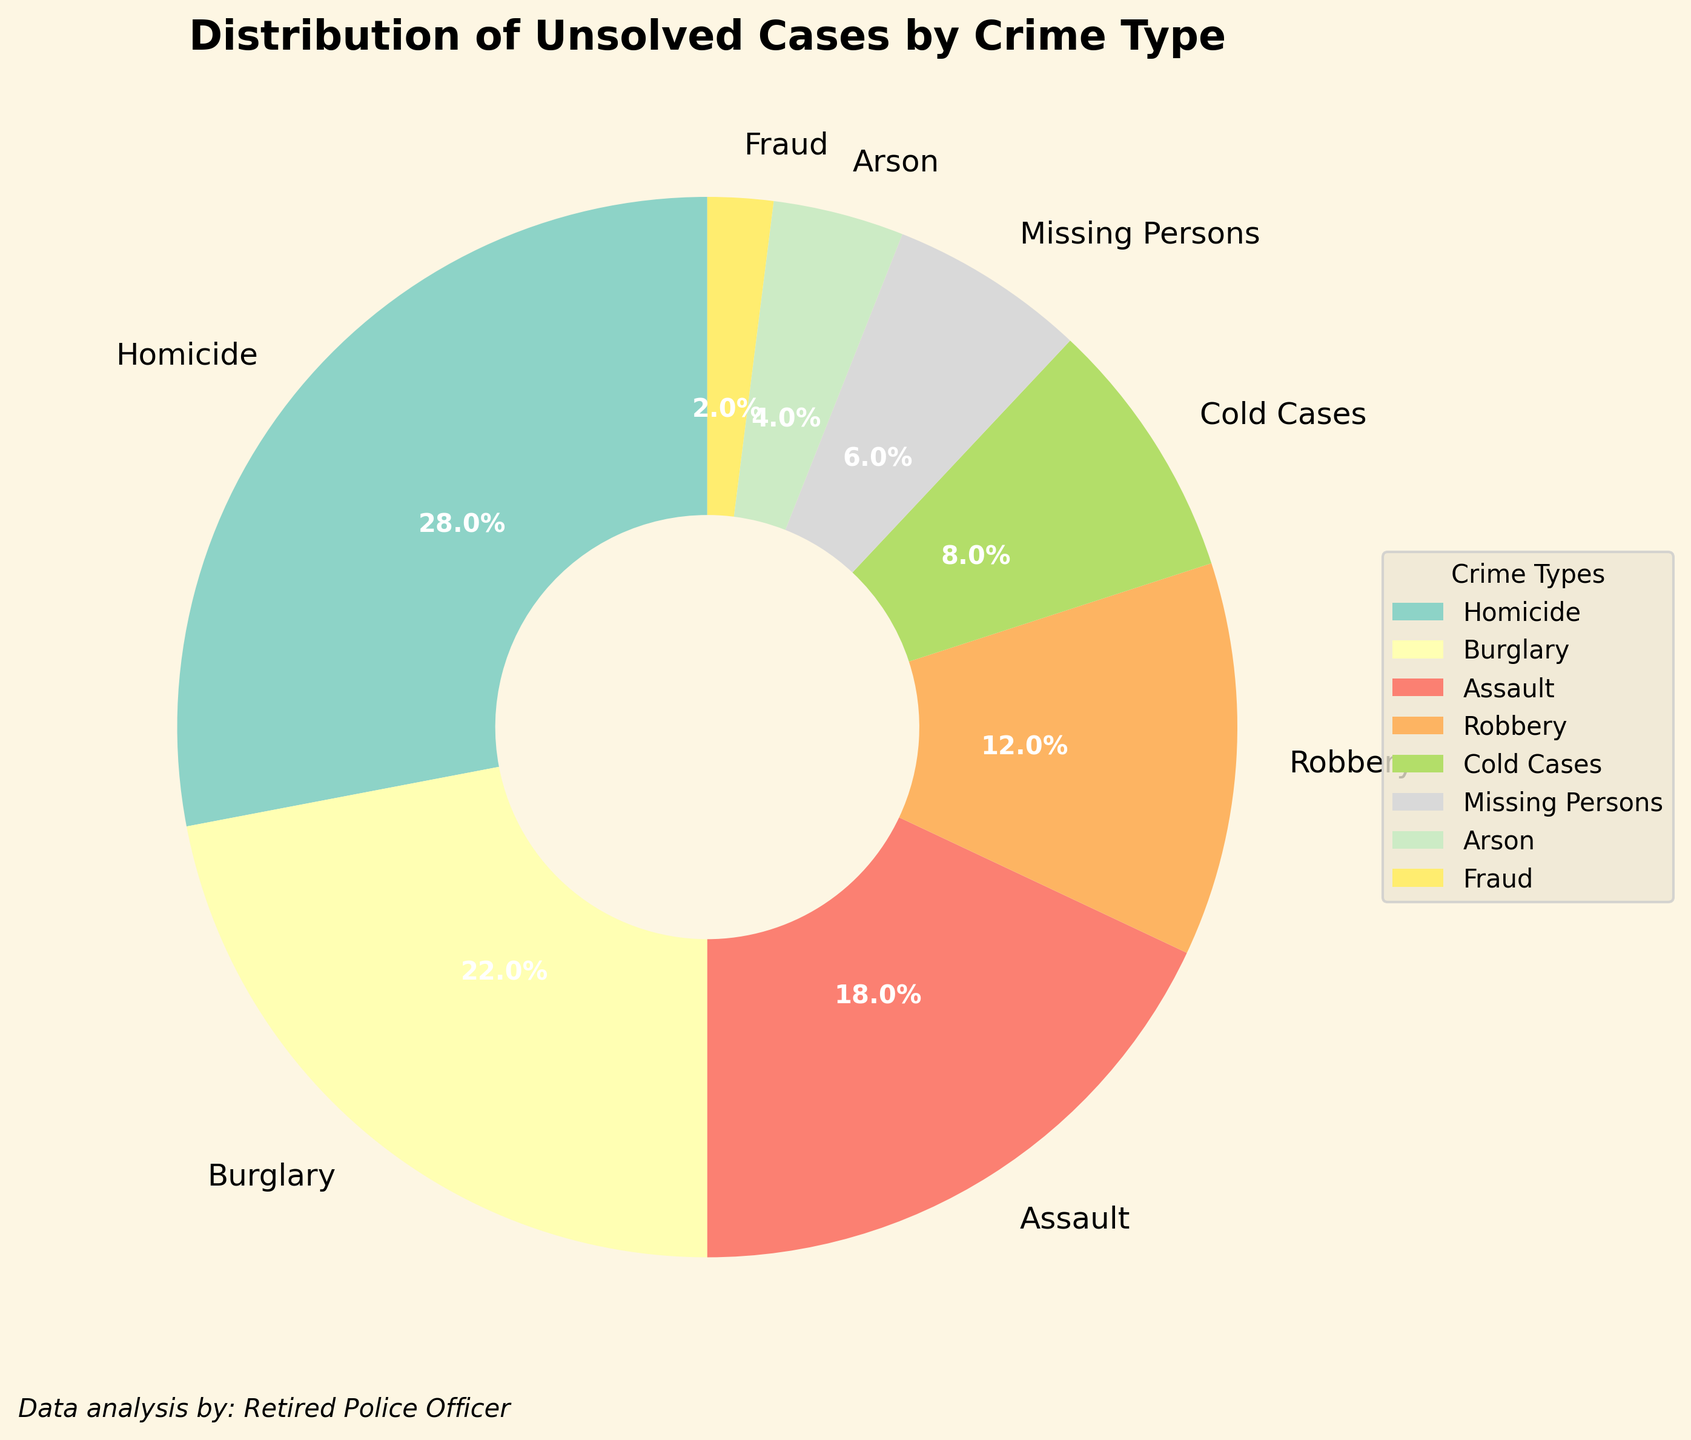What percentage of unsolved cases are due to robbery? To find the percentage of unsolved cases due to robbery, look at the segment labeled "Robbery" in the pie chart. The corresponding percentage displayed is 12%.
Answer: 12% Which crime type has the highest percentage of unsolved cases? To determine the crime type with the highest percentage of unsolved cases, identify the segment with the largest portion in the pie chart. The largest segment is labeled "Homicide" with a percentage of 28%.
Answer: Homicide with 28% What is the combined percentage of unsolved cases for burglary and assault? Sum the percentages for both "Burglary" and "Assault". The percentage for burglary is 22% and for assault is 18%. Adding these together gives 22% + 18% = 40%.
Answer: 40% Are there more unsolved cases for arson or fraud? Compare the percentages for "Arson" and "Fraud". The segment for arson is 4%, while the segment for fraud is 2%. Since 4% is greater than 2%, there are more unsolved cases for arson than fraud.
Answer: Arson with 4% What is the difference in unsolved case percentages between missing persons and cold cases? Subtract the percentage of missing persons from the percentage of cold cases. Cold cases have 8% and missing persons have 6%. The difference is 8% - 6% = 2%.
Answer: 2% Which has more unsolved cases, robbery, or arson and fraud combined? First, add the percentages for arson and fraud. Arson is 4% and fraud is 2%, so 4% + 2% = 6%. Compare this to the robbery percentage of 12%. Since 12% is greater than 6%, robbery has more unsolved cases than arson and fraud combined.
Answer: Robbery with 12% List the crime types that make up at least 10% of the unsolved cases. Identify the segments in the pie chart that are at least 10%. These segments are "Homicide" (28%), "Burglary" (22%), "Assault" (18%), and "Robbery" (12%).
Answer: Homicide, Burglary, Assault, Robbery What is the total percentage of unsolved cases attributed to non-violent crimes (Burglary, Fraud)? Add the percentages for non-violent crimes. Burglary is 22% and fraud is 2%, giving a total of 22% + 2% = 24%.
Answer: 24% How does the percentage of unsolved cold cases compare to the percentage of unsolved arson cases? Compare the percentages of cold cases and arson cases. Cold cases have 8% and arson cases have 4%. Since 8% is greater than 4%, cold cases have a higher percentage.
Answer: Cold cases with 8% What is the combined percentage of unsolved cases for all crime types other than homicide and burglary? Add together the percentages for all crime types except homicide and burglary. The percentages are 18% (Assault) + 12% (Robbery) + 8% (Cold Cases) + 6% (Missing Persons) + 4% (Arson) + 2% (Fraud), which sums to 50%.
Answer: 50% 